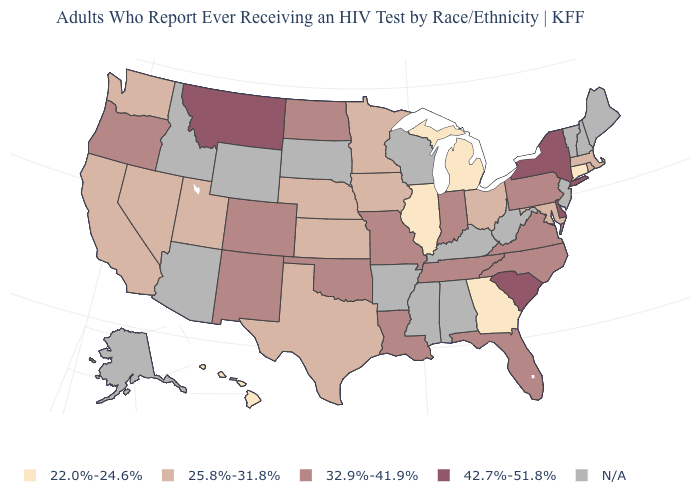Which states have the highest value in the USA?
Keep it brief. Delaware, Montana, New York, South Carolina. Does Hawaii have the lowest value in the West?
Short answer required. Yes. Name the states that have a value in the range 22.0%-24.6%?
Short answer required. Connecticut, Georgia, Hawaii, Illinois, Michigan. Name the states that have a value in the range 25.8%-31.8%?
Be succinct. California, Iowa, Kansas, Maryland, Massachusetts, Minnesota, Nebraska, Nevada, Ohio, Rhode Island, Texas, Utah, Washington. Does Montana have the highest value in the USA?
Concise answer only. Yes. Which states have the lowest value in the USA?
Quick response, please. Connecticut, Georgia, Hawaii, Illinois, Michigan. What is the lowest value in the South?
Short answer required. 22.0%-24.6%. Which states have the lowest value in the MidWest?
Be succinct. Illinois, Michigan. Name the states that have a value in the range 22.0%-24.6%?
Give a very brief answer. Connecticut, Georgia, Hawaii, Illinois, Michigan. Name the states that have a value in the range 42.7%-51.8%?
Concise answer only. Delaware, Montana, New York, South Carolina. Among the states that border Colorado , which have the highest value?
Short answer required. New Mexico, Oklahoma. Name the states that have a value in the range N/A?
Quick response, please. Alabama, Alaska, Arizona, Arkansas, Idaho, Kentucky, Maine, Mississippi, New Hampshire, New Jersey, South Dakota, Vermont, West Virginia, Wisconsin, Wyoming. Among the states that border Wyoming , does Colorado have the lowest value?
Write a very short answer. No. What is the value of Utah?
Write a very short answer. 25.8%-31.8%. 